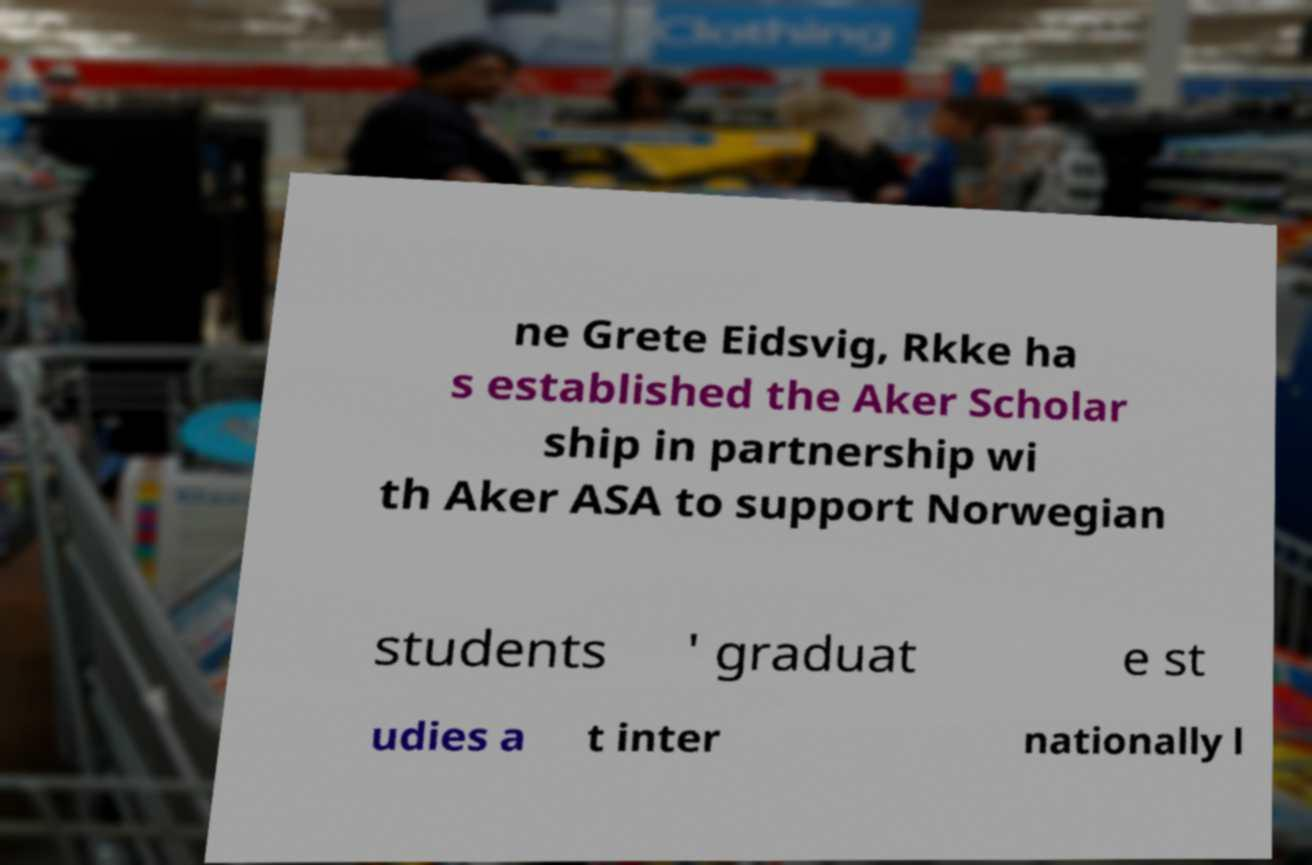What messages or text are displayed in this image? I need them in a readable, typed format. ne Grete Eidsvig, Rkke ha s established the Aker Scholar ship in partnership wi th Aker ASA to support Norwegian students ' graduat e st udies a t inter nationally l 